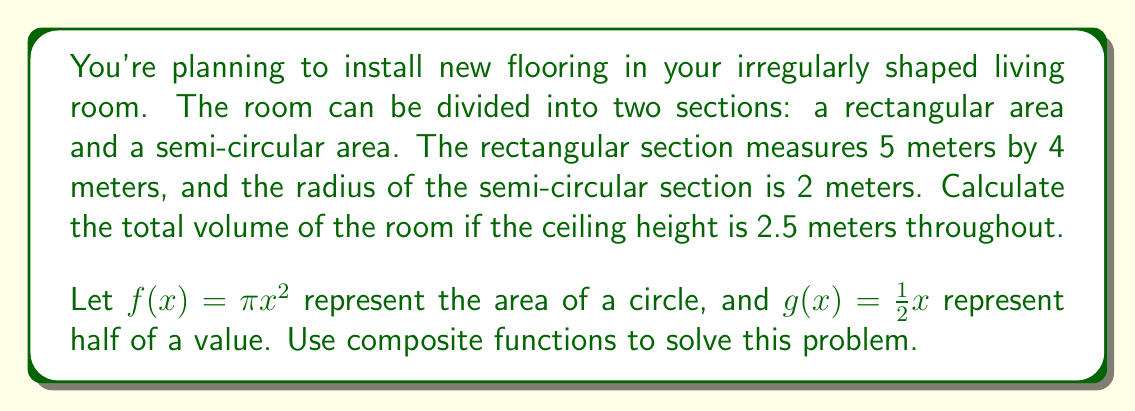What is the answer to this math problem? Let's approach this step-by-step:

1) First, we need to calculate the area of the entire floor:

   a) Rectangular section: $A_r = 5m \times 4m = 20m^2$
   
   b) Semi-circular section: We need to use the composite function $(g \circ f)(r)$
      $f(r) = \pi r^2 = \pi (2m)^2 = 4\pi m^2$
      $g(f(r)) = \frac{1}{2}(4\pi m^2) = 2\pi m^2$

   c) Total floor area: $A_{total} = A_r + (g \circ f)(r) = 20m^2 + 2\pi m^2 \approx 26.28m^2$

2) Now, to find the volume, we multiply the total floor area by the height:

   $V = A_{total} \times h = 26.28m^2 \times 2.5m = 65.7m^3$

Therefore, the total volume of the room is approximately 65.7 cubic meters.
Answer: $65.7m^3$ 